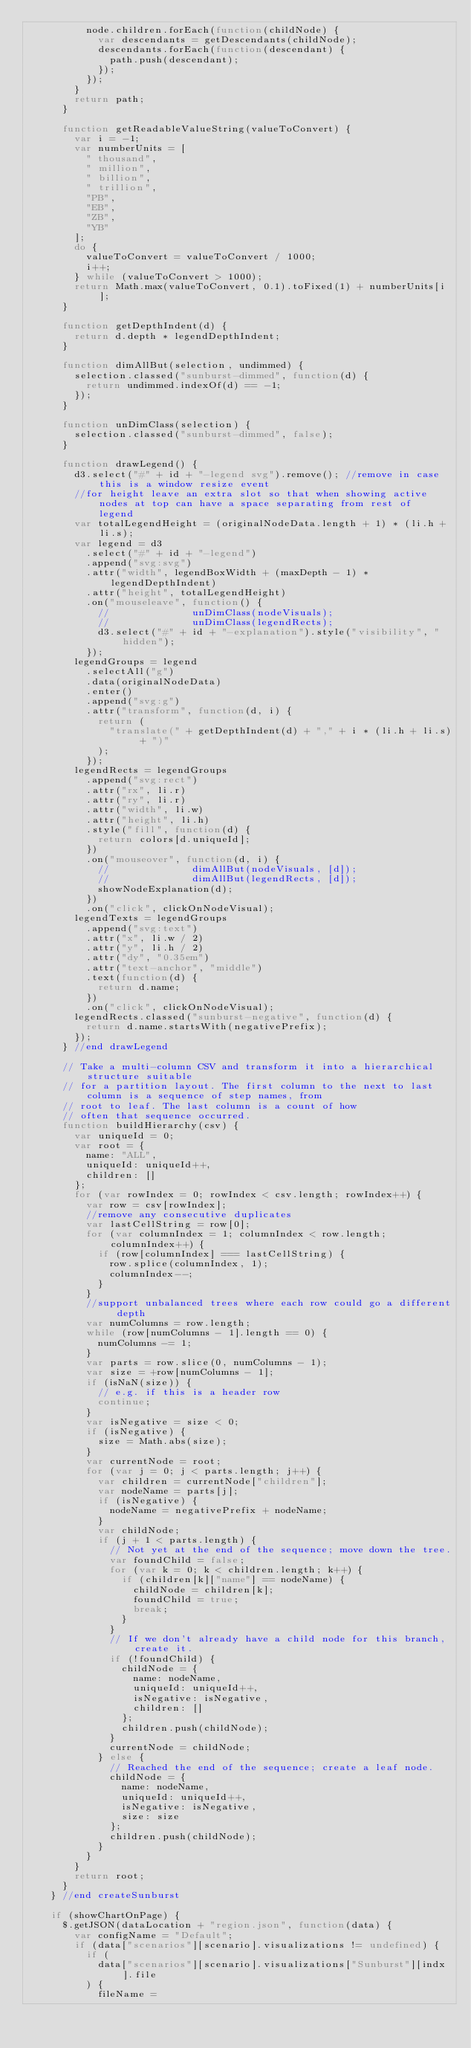Convert code to text. <code><loc_0><loc_0><loc_500><loc_500><_JavaScript_>          node.children.forEach(function(childNode) {
            var descendants = getDescendants(childNode);
            descendants.forEach(function(descendant) {
              path.push(descendant);
            });
          });
        }
        return path;
      }

      function getReadableValueString(valueToConvert) {
        var i = -1;
        var numberUnits = [
          " thousand",
          " million",
          " billion",
          " trillion",
          "PB",
          "EB",
          "ZB",
          "YB"
        ];
        do {
          valueToConvert = valueToConvert / 1000;
          i++;
        } while (valueToConvert > 1000);
        return Math.max(valueToConvert, 0.1).toFixed(1) + numberUnits[i];
      }

      function getDepthIndent(d) {
        return d.depth * legendDepthIndent;
      }

      function dimAllBut(selection, undimmed) {
        selection.classed("sunburst-dimmed", function(d) {
          return undimmed.indexOf(d) == -1;
        });
      }

      function unDimClass(selection) {
        selection.classed("sunburst-dimmed", false);
      }

      function drawLegend() {
        d3.select("#" + id + "-legend svg").remove(); //remove in case this is a window resize event
        //for height leave an extra slot so that when showing active nodes at top can have a space separating from rest of legend
        var totalLegendHeight = (originalNodeData.length + 1) * (li.h + li.s);
        var legend = d3
          .select("#" + id + "-legend")
          .append("svg:svg")
          .attr("width", legendBoxWidth + (maxDepth - 1) * legendDepthIndent)
          .attr("height", totalLegendHeight)
          .on("mouseleave", function() {
            // 				unDimClass(nodeVisuals);
            // 				unDimClass(legendRects);
            d3.select("#" + id + "-explanation").style("visibility", "hidden");
          });
        legendGroups = legend
          .selectAll("g")
          .data(originalNodeData)
          .enter()
          .append("svg:g")
          .attr("transform", function(d, i) {
            return (
              "translate(" + getDepthIndent(d) + "," + i * (li.h + li.s) + ")"
            );
          });
        legendRects = legendGroups
          .append("svg:rect")
          .attr("rx", li.r)
          .attr("ry", li.r)
          .attr("width", li.w)
          .attr("height", li.h)
          .style("fill", function(d) {
            return colors[d.uniqueId];
          })
          .on("mouseover", function(d, i) {
            // 				dimAllBut(nodeVisuals, [d]);
            // 				dimAllBut(legendRects, [d]);
            showNodeExplanation(d);
          })
          .on("click", clickOnNodeVisual);
        legendTexts = legendGroups
          .append("svg:text")
          .attr("x", li.w / 2)
          .attr("y", li.h / 2)
          .attr("dy", "0.35em")
          .attr("text-anchor", "middle")
          .text(function(d) {
            return d.name;
          })
          .on("click", clickOnNodeVisual);
        legendRects.classed("sunburst-negative", function(d) {
          return d.name.startsWith(negativePrefix);
        });
      } //end drawLegend

      // Take a multi-column CSV and transform it into a hierarchical structure suitable
      // for a partition layout. The first column to the next to last column is a sequence of step names, from
      // root to leaf. The last column is a count of how
      // often that sequence occurred.
      function buildHierarchy(csv) {
        var uniqueId = 0;
        var root = {
          name: "ALL",
          uniqueId: uniqueId++,
          children: []
        };
        for (var rowIndex = 0; rowIndex < csv.length; rowIndex++) {
          var row = csv[rowIndex];
          //remove any consecutive duplicates
          var lastCellString = row[0];
          for (var columnIndex = 1; columnIndex < row.length; columnIndex++) {
            if (row[columnIndex] === lastCellString) {
              row.splice(columnIndex, 1);
              columnIndex--;
            }
          }
          //support unbalanced trees where each row could go a different depth
          var numColumns = row.length;
          while (row[numColumns - 1].length == 0) {
            numColumns -= 1;
          }
          var parts = row.slice(0, numColumns - 1);
          var size = +row[numColumns - 1];
          if (isNaN(size)) {
            // e.g. if this is a header row
            continue;
          }
          var isNegative = size < 0;
          if (isNegative) {
            size = Math.abs(size);
          }
          var currentNode = root;
          for (var j = 0; j < parts.length; j++) {
            var children = currentNode["children"];
            var nodeName = parts[j];
            if (isNegative) {
              nodeName = negativePrefix + nodeName;
            }
            var childNode;
            if (j + 1 < parts.length) {
              // Not yet at the end of the sequence; move down the tree.
              var foundChild = false;
              for (var k = 0; k < children.length; k++) {
                if (children[k]["name"] == nodeName) {
                  childNode = children[k];
                  foundChild = true;
                  break;
                }
              }
              // If we don't already have a child node for this branch, create it.
              if (!foundChild) {
                childNode = {
                  name: nodeName,
                  uniqueId: uniqueId++,
                  isNegative: isNegative,
                  children: []
                };
                children.push(childNode);
              }
              currentNode = childNode;
            } else {
              // Reached the end of the sequence; create a leaf node.
              childNode = {
                name: nodeName,
                uniqueId: uniqueId++,
                isNegative: isNegative,
                size: size
              };
              children.push(childNode);
            }
          }
        }
        return root;
      }
    } //end createSunburst

    if (showChartOnPage) {
      $.getJSON(dataLocation + "region.json", function(data) {
        var configName = "Default";
        if (data["scenarios"][scenario].visualizations != undefined) {
          if (
            data["scenarios"][scenario].visualizations["Sunburst"][indx].file
          ) {
            fileName =</code> 